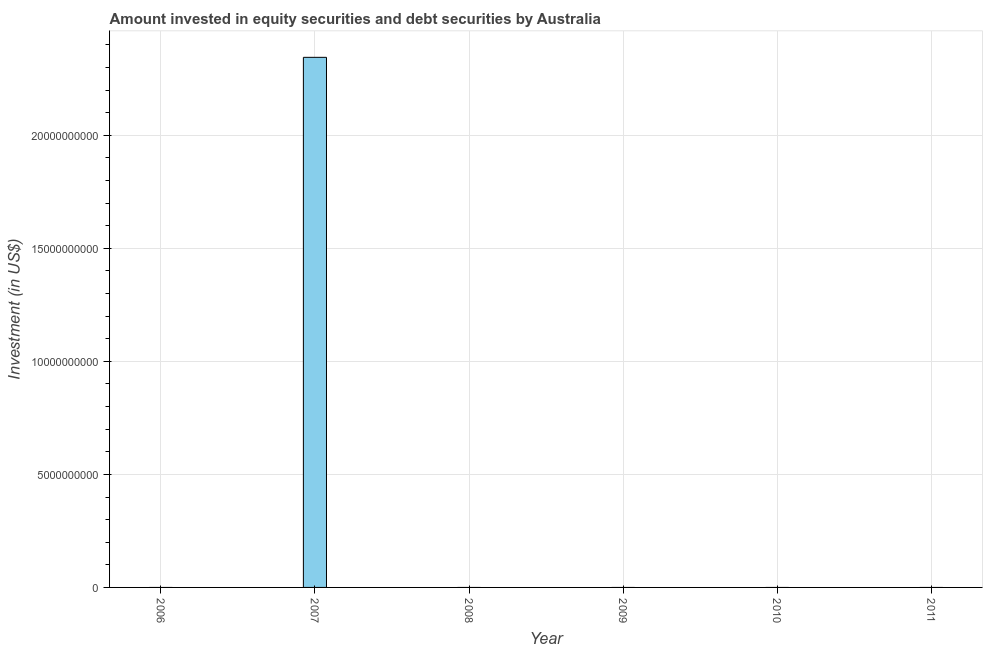Does the graph contain any zero values?
Make the answer very short. Yes. Does the graph contain grids?
Offer a very short reply. Yes. What is the title of the graph?
Offer a very short reply. Amount invested in equity securities and debt securities by Australia. What is the label or title of the Y-axis?
Your answer should be very brief. Investment (in US$). Across all years, what is the maximum portfolio investment?
Offer a terse response. 2.35e+1. Across all years, what is the minimum portfolio investment?
Keep it short and to the point. 0. In which year was the portfolio investment maximum?
Offer a terse response. 2007. What is the sum of the portfolio investment?
Make the answer very short. 2.35e+1. What is the average portfolio investment per year?
Make the answer very short. 3.91e+09. What is the median portfolio investment?
Ensure brevity in your answer.  0. In how many years, is the portfolio investment greater than 18000000000 US$?
Provide a short and direct response. 1. What is the difference between the highest and the lowest portfolio investment?
Provide a short and direct response. 2.35e+1. Are all the bars in the graph horizontal?
Ensure brevity in your answer.  No. Are the values on the major ticks of Y-axis written in scientific E-notation?
Make the answer very short. No. What is the Investment (in US$) of 2007?
Provide a succinct answer. 2.35e+1. What is the Investment (in US$) of 2010?
Your response must be concise. 0. 